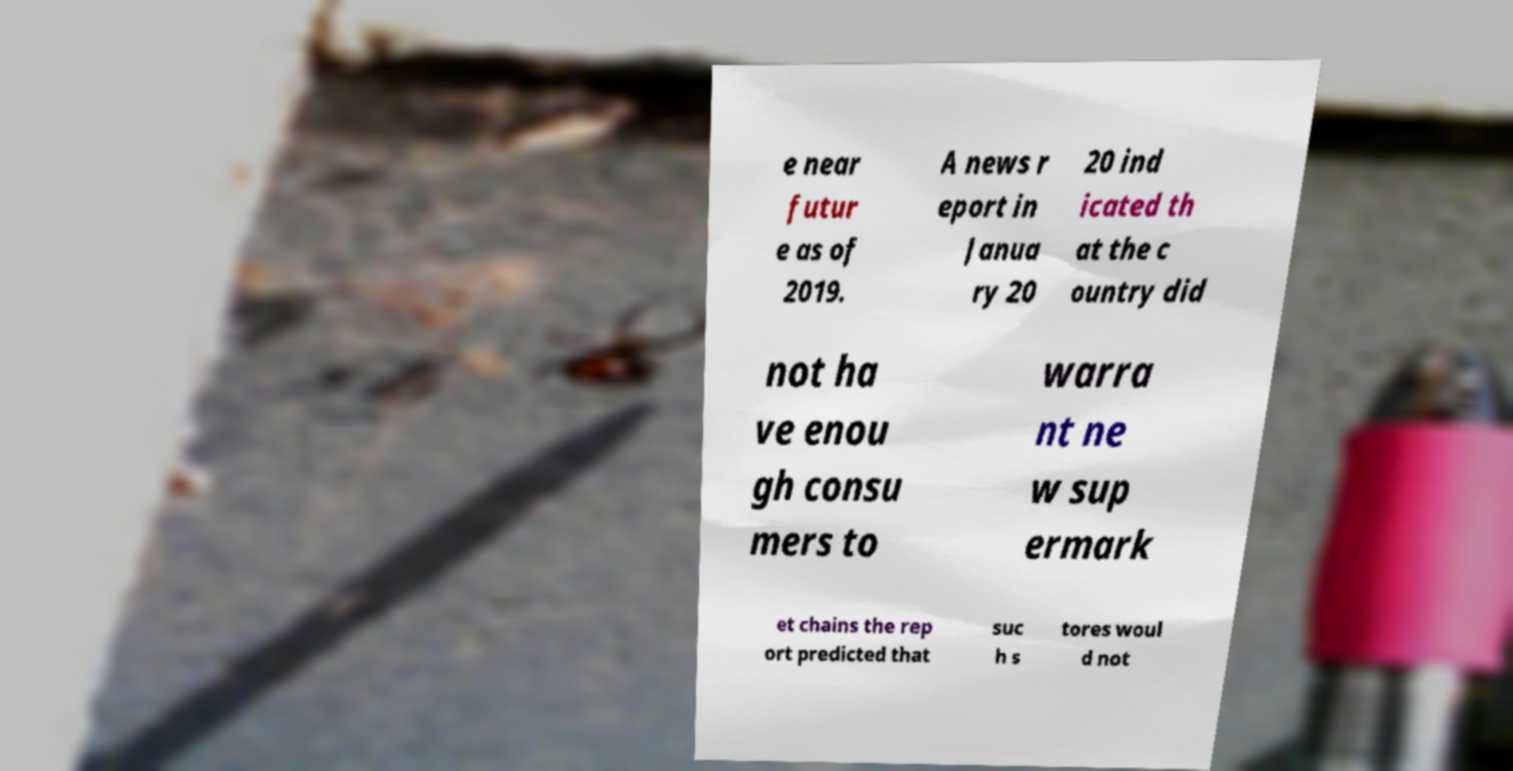Please identify and transcribe the text found in this image. e near futur e as of 2019. A news r eport in Janua ry 20 20 ind icated th at the c ountry did not ha ve enou gh consu mers to warra nt ne w sup ermark et chains the rep ort predicted that suc h s tores woul d not 